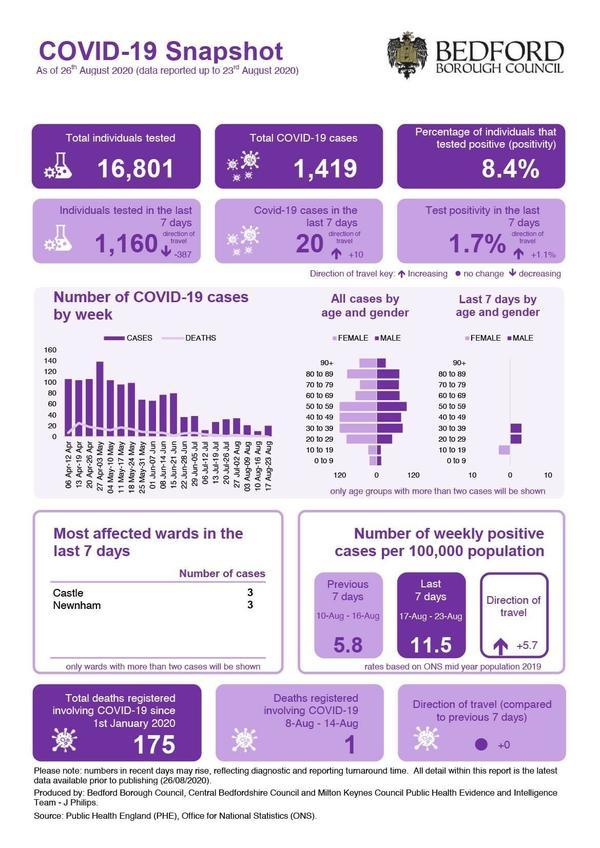What is the number of COVID-19 cases in  Newnham as of 26th August 2020?
Answer the question with a short phrase. 3 What is the percentage of individuals that tested positive in Bedford Borough as of 26th August 2020? 8.4% What is the total number of COVID-19 cases reported in Bedford Borough as of 26th August 2020? 1,419 What is the total number of COVID-19 deaths registered since 1st January 2020 in Bedford Borough? 175 Which two wards in Bedford Borough were most affected by COVID-19 as of 26th August 2020? Castle, Newnham How many Covid-19 deaths were registered between 8-14 Aug 2020 in Bedford Borough? 1 What is the total number of individuals tested for the COVID-19 virus in Bedford Borough as of 26th August 2020? 16,801 